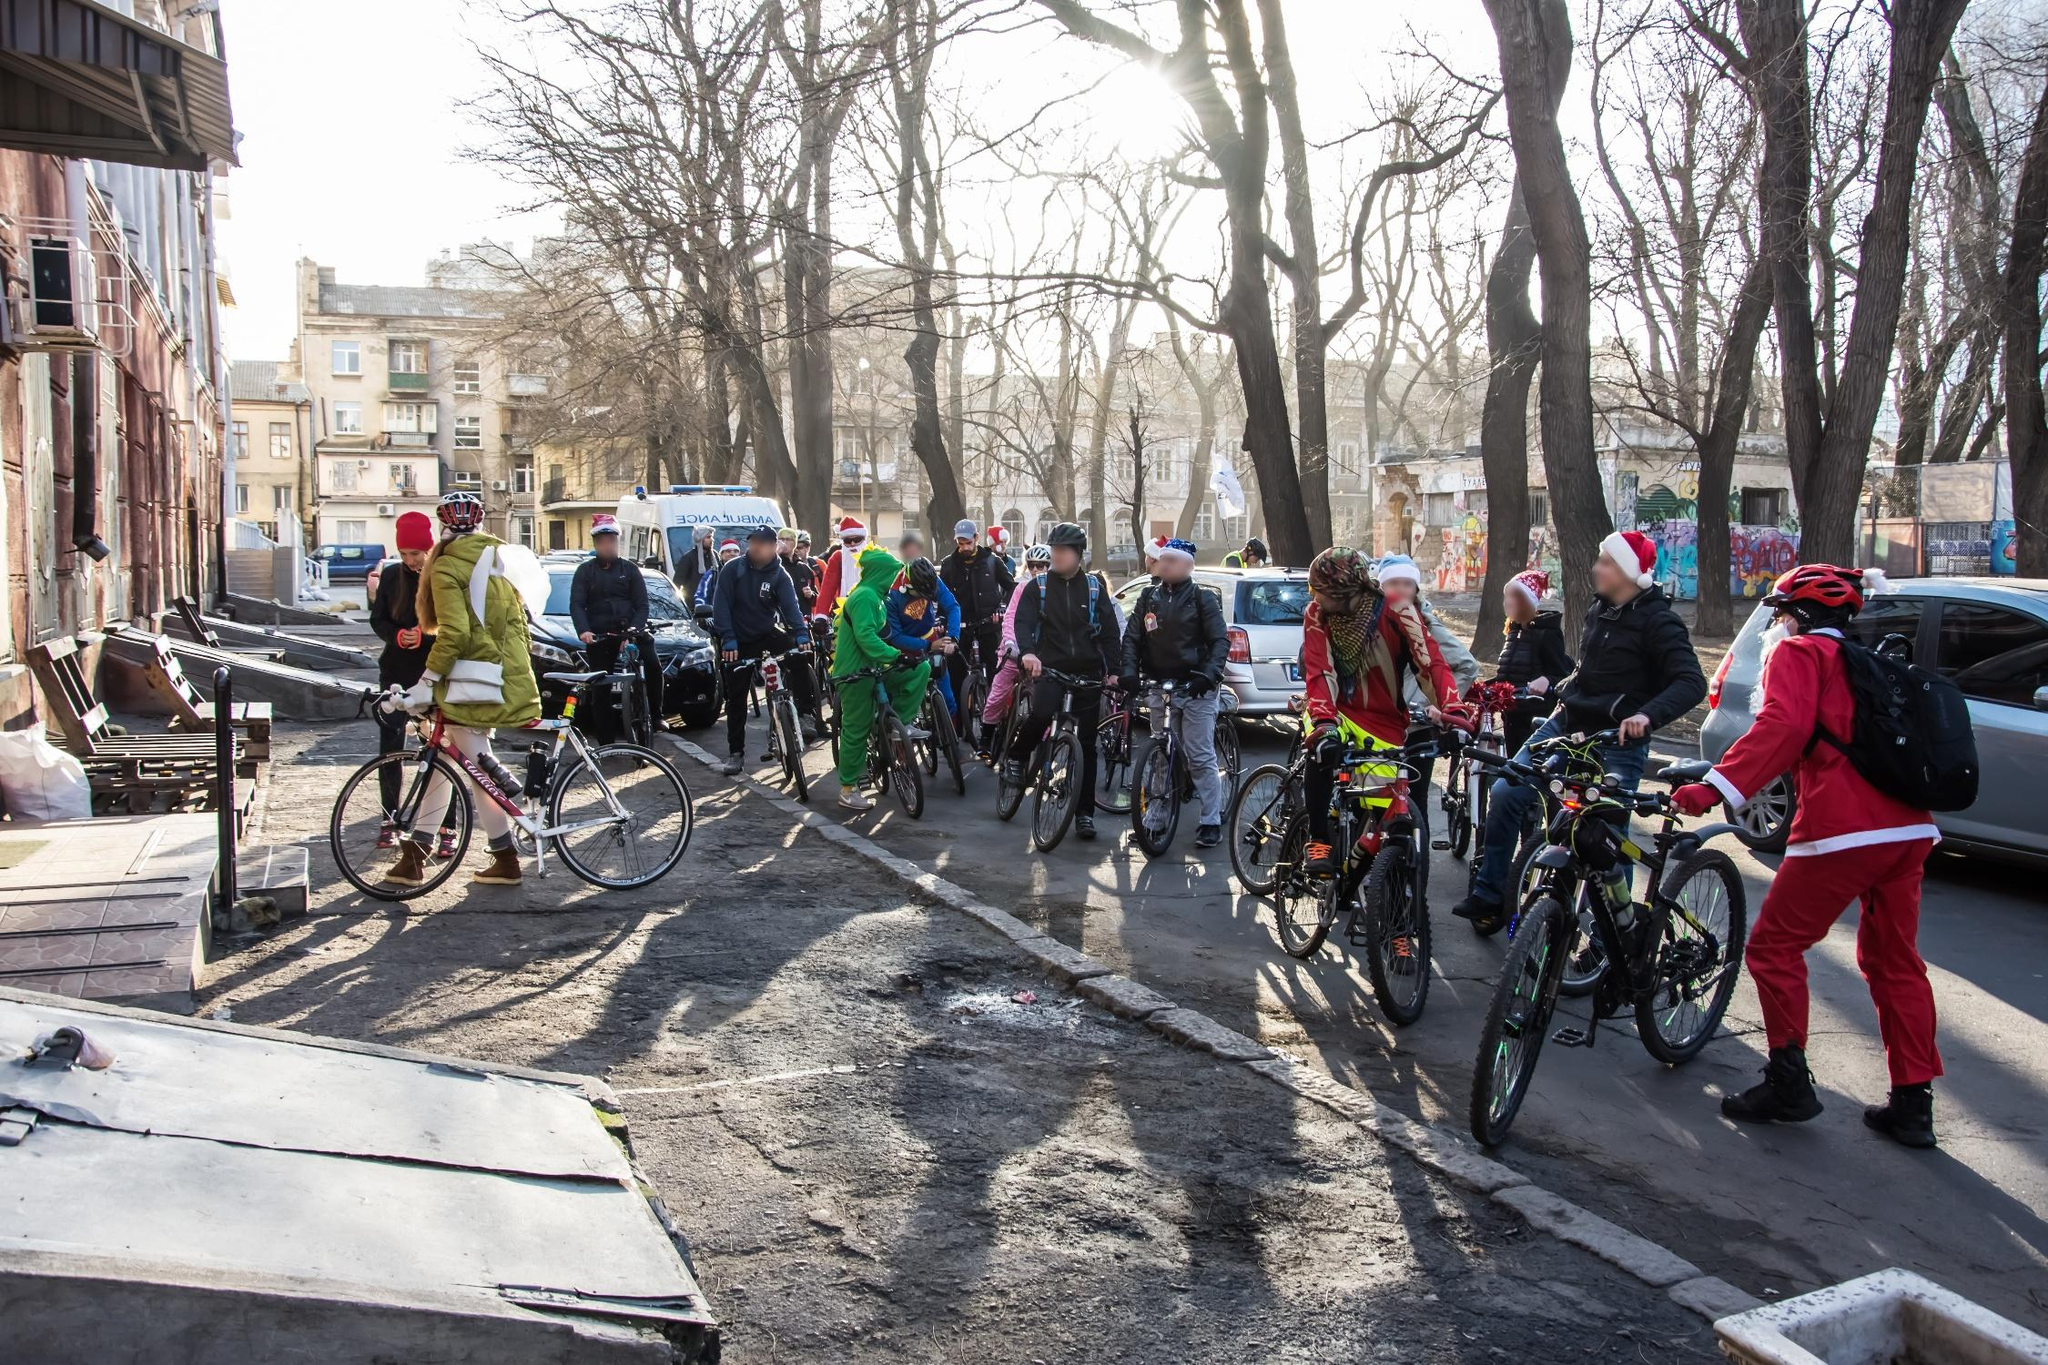Describe the atmosphere of the event depicted in the image. The atmosphere of the event depicted in the image is one of festivity, joy, and community spirit. The participants, dressed in colorful and festive costumes, add a sense of celebration and excitement to the scene. The low winter sunlight casting long shadows and the bare trees lining the city street suggest a cool, crisp day, perfectly complementing the vibrant attire of the cyclists. The communal gathering suggests a shared purpose or theme, likely a festive ride in celebration of a holiday or a fun, themed event. The overall mood is lively, cheerful, and filled with a sense of camaraderie as people come together to enjoy a collective outdoor activity within the urban landscape. 